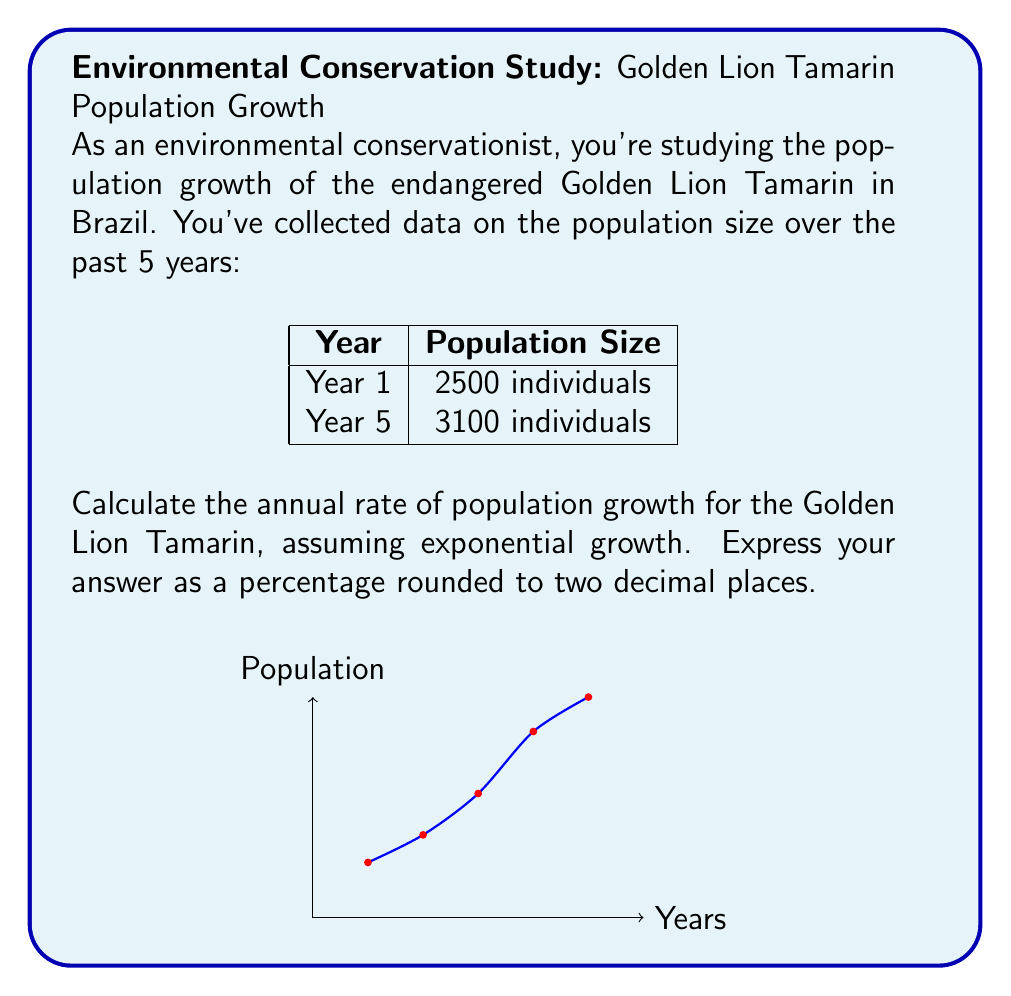Solve this math problem. Let's approach this step-by-step:

1) The formula for exponential growth is:

   $$P(t) = P_0 \cdot e^{rt}$$

   Where:
   $P(t)$ is the population at time $t$
   $P_0$ is the initial population
   $r$ is the growth rate
   $t$ is the time period

2) We know:
   $P_0 = 2500$ (initial population)
   $P(t) = 3100$ (final population)
   $t = 5 - 1 = 4$ years

3) Substituting these values into the formula:

   $$3100 = 2500 \cdot e^{4r}$$

4) Dividing both sides by 2500:

   $$1.24 = e^{4r}$$

5) Taking the natural logarithm of both sides:

   $$\ln(1.24) = 4r$$

6) Solving for $r$:

   $$r = \frac{\ln(1.24)}{4} \approx 0.0545$$

7) To express this as a percentage, we multiply by 100:

   $$0.0545 \cdot 100 \approx 5.45\%$$

8) Rounding to two decimal places: 5.45%

This means the Golden Lion Tamarin population is growing at about 5.45% per year.
Answer: 5.45% 